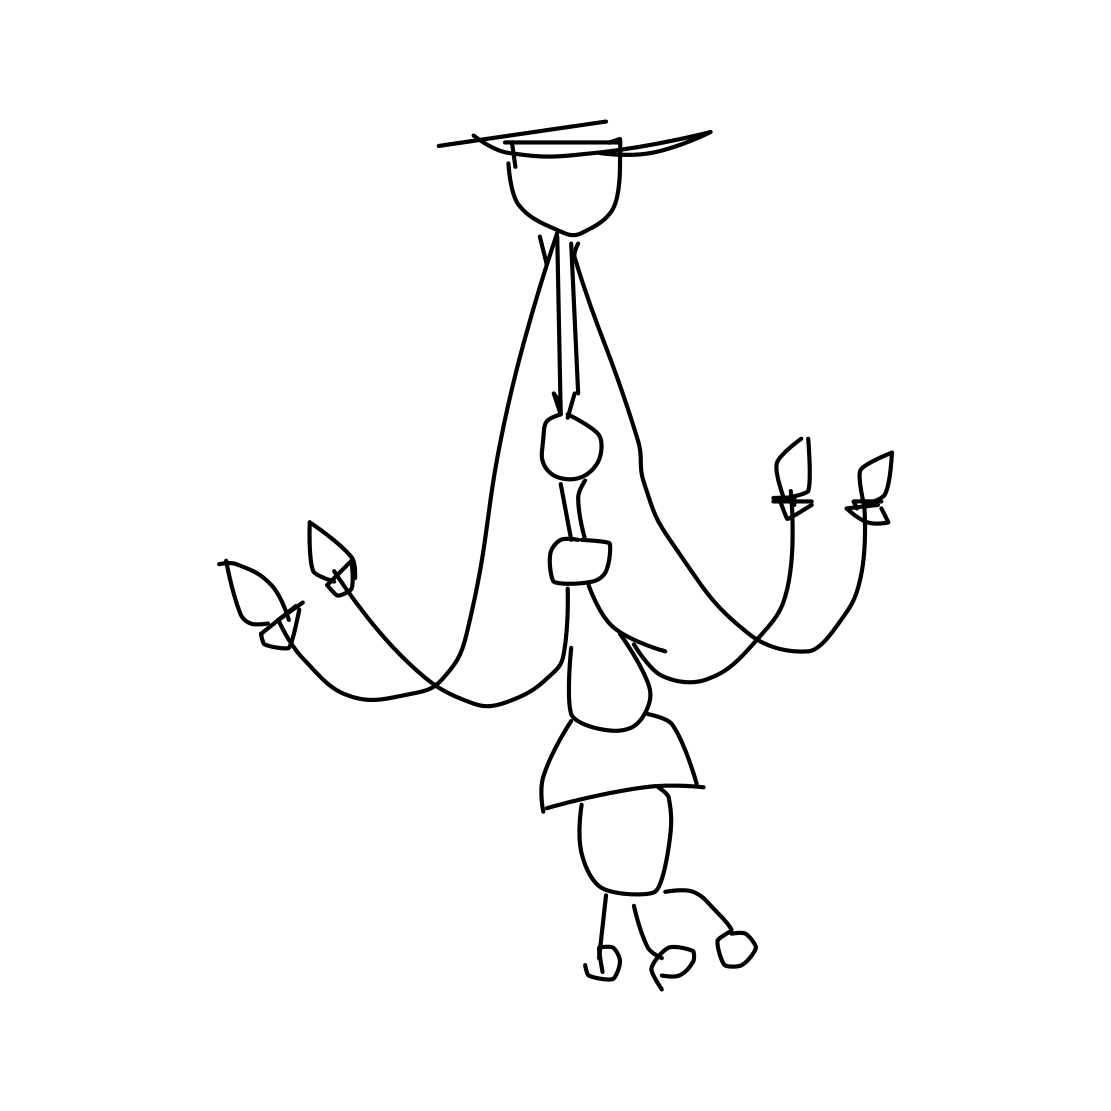How many candles does this chandelier hold? The chandelier in the picture is designed to hold four candles, one at the end of each of its arms. 